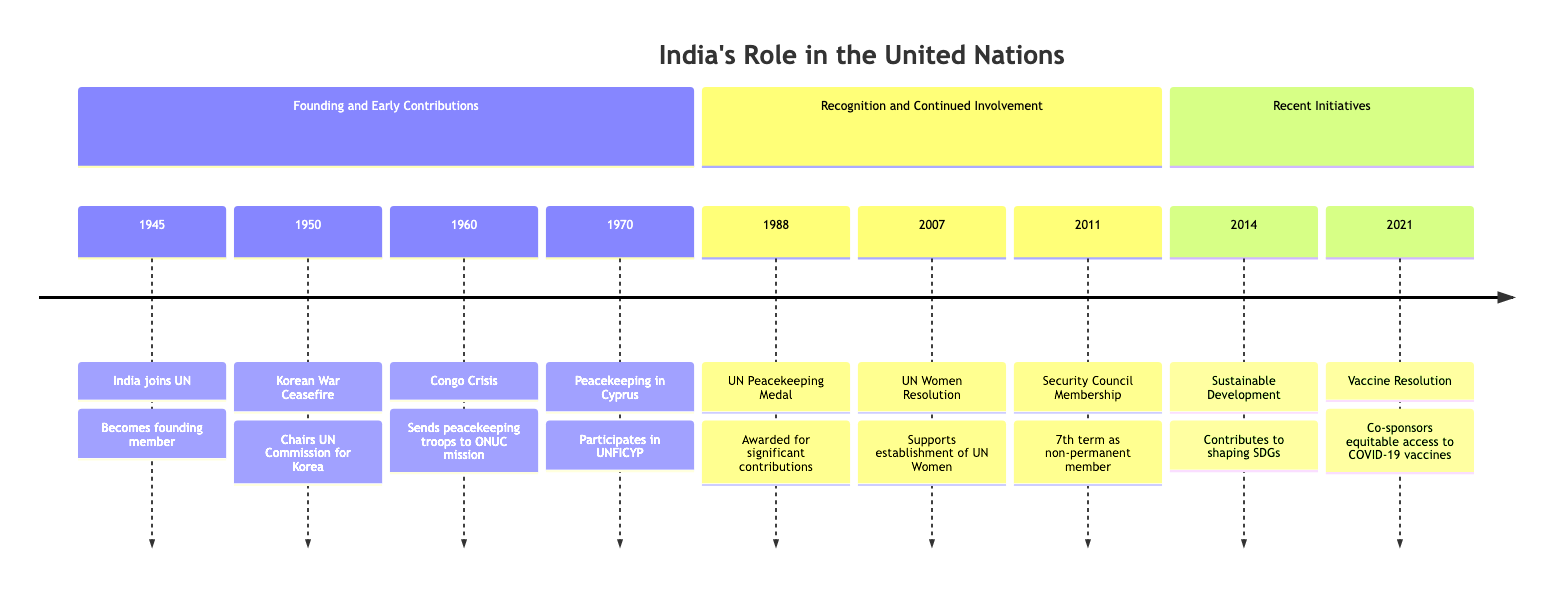What year did India join the United Nations? According to the diagram, India joined the UN in 1945, as indicated in the section for its founding and early contributions.
Answer: 1945 How many times has India served as a non-permanent member of the Security Council? The diagram states that India has served as a non-permanent member of the Security Council for 7 terms.
Answer: 7 Which UN resolution did India support in 2007? The diagram mentions that India supported the establishment of UN Women in 2007 as a significant contribution.
Answer: UN Women Resolution What is the significance of the year 1988 for India in the UN context? In 1988, India was awarded the UN Peacekeeping Medal for its significant contributions to UN peacekeeping missions as shown in the recognition and continued involvement section.
Answer: UN Peacekeeping Medal What mission did India participate in during the Congo Crisis? The diagram indicates that during the Congo Crisis in 1960, India sent peacekeeping troops to ONUC mission, highlighting its early contributions.
Answer: ONUC mission Which initiative did India co-sponsor in 2021? The diagram indicates that in 2021, India co-sponsored a resolution for equitable access to COVID-19 vaccines, marking its recent initiatives.
Answer: Vaccine Resolution Identify two significant peacekeeping missions that India participated in according to the diagram. The diagram lists India's participation in the UNFICYP in Cyprus (1970) and the ONUC mission in the Congo (1960), showcasing its ongoing involvement in peacekeeping efforts.
Answer: ONUC mission, UNFICYP What key document does the diagram attribute to India's contributions in 2014? In 2014, the diagram notes that India contributed to shaping the Sustainable Development Goals (SDGs), indicating its role in global governance and development initiatives.
Answer: Sustainable Development Goals 